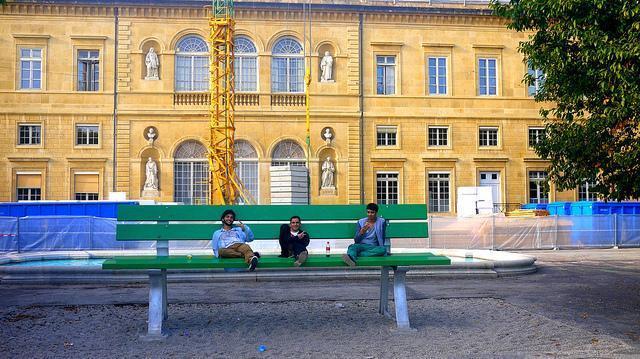How many men are sitting on the bench?
Give a very brief answer. 3. 